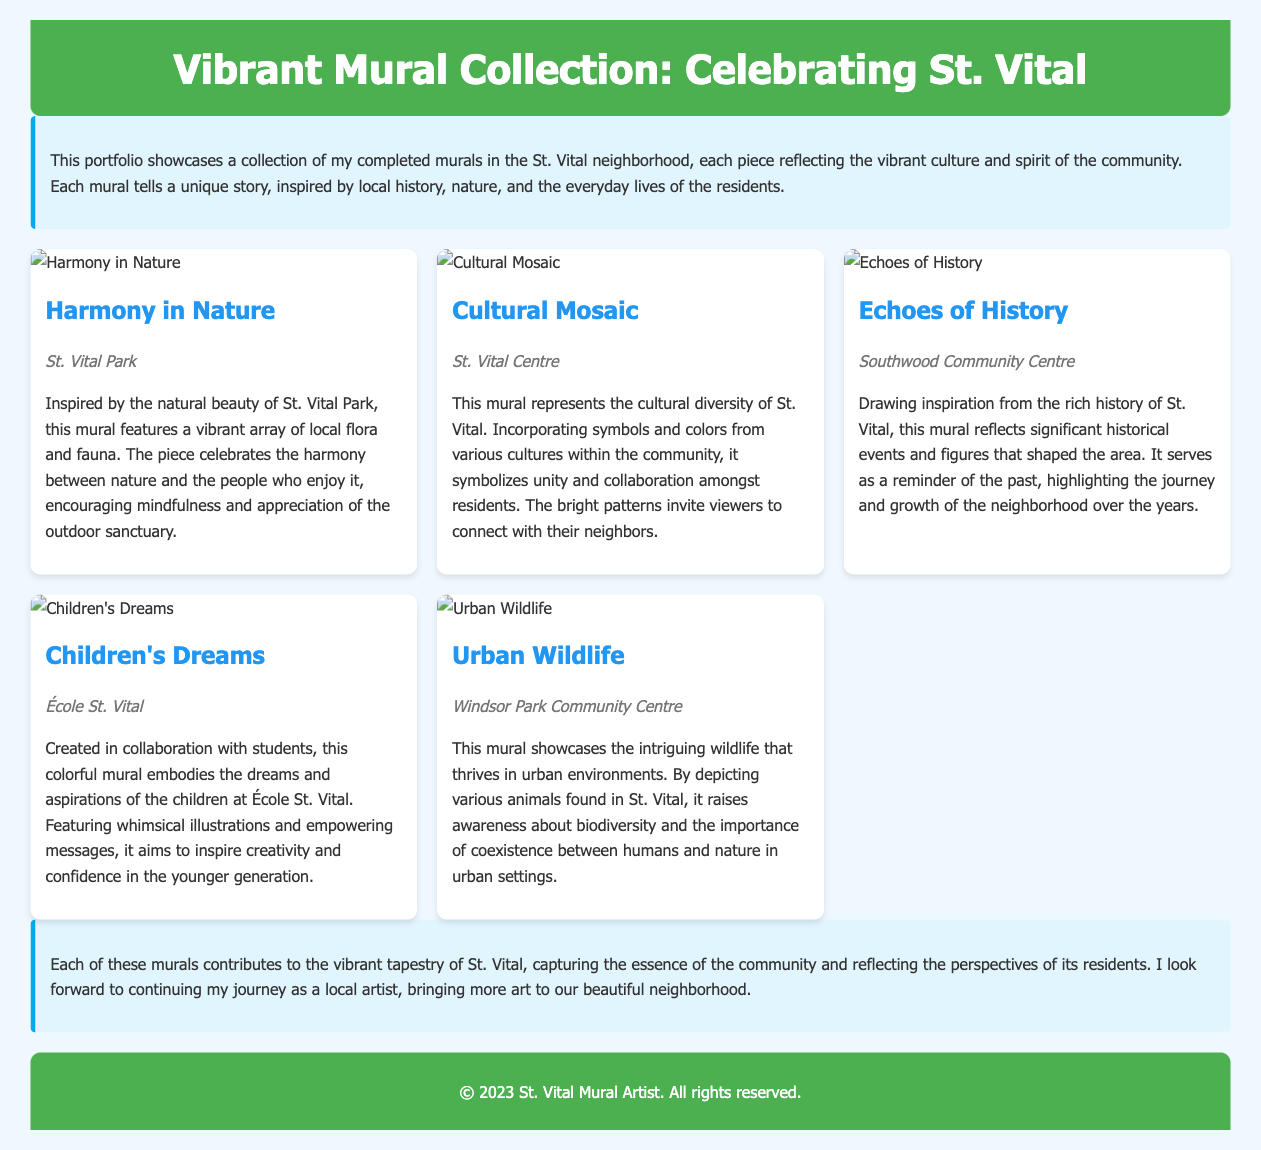What is the title of the portfolio? The title of the portfolio is stated in the header section of the document.
Answer: Vibrant Mural Collection: Celebrating St. Vital How many murals are featured in the document? The document includes a section describing each mural, which can be counted for a total.
Answer: Five What is the location of the mural "Harmony in Nature"? The mural's location is provided in a designated area within the mural card.
Answer: St. Vital Park What is the main theme of the "Cultural Mosaic" mural? The theme is revealed in the description provided for that specific mural.
Answer: Cultural diversity Who collaborated on the "Children's Dreams" mural? The collaboration partner is mentioned in the mural description.
Answer: Students What inspiration does the mural "Echoes of History" draw from? The inspiration is detailed within the mural's description section.
Answer: Rich history of St. Vital What color is used prominently in the header? The color can be identified from the design aspects outlined in the document.
Answer: Green What does the "Urban Wildlife" mural aim to raise awareness about? The aim is described clearly in the mural's information segment.
Answer: Biodiversity What style is used for the text throughout the document? The document mentions the font choice in the CSS for text presentation.
Answer: Segoe UI 